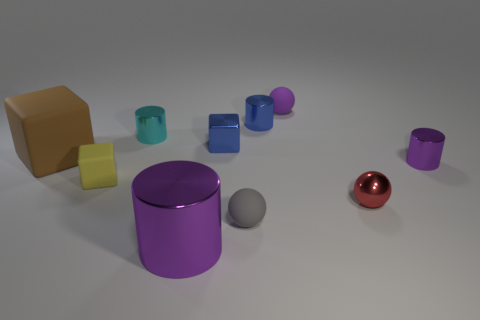Subtract all cylinders. How many objects are left? 6 Subtract 0 cyan blocks. How many objects are left? 10 Subtract all tiny red metal objects. Subtract all blue blocks. How many objects are left? 8 Add 7 brown objects. How many brown objects are left? 8 Add 5 small metallic objects. How many small metallic objects exist? 10 